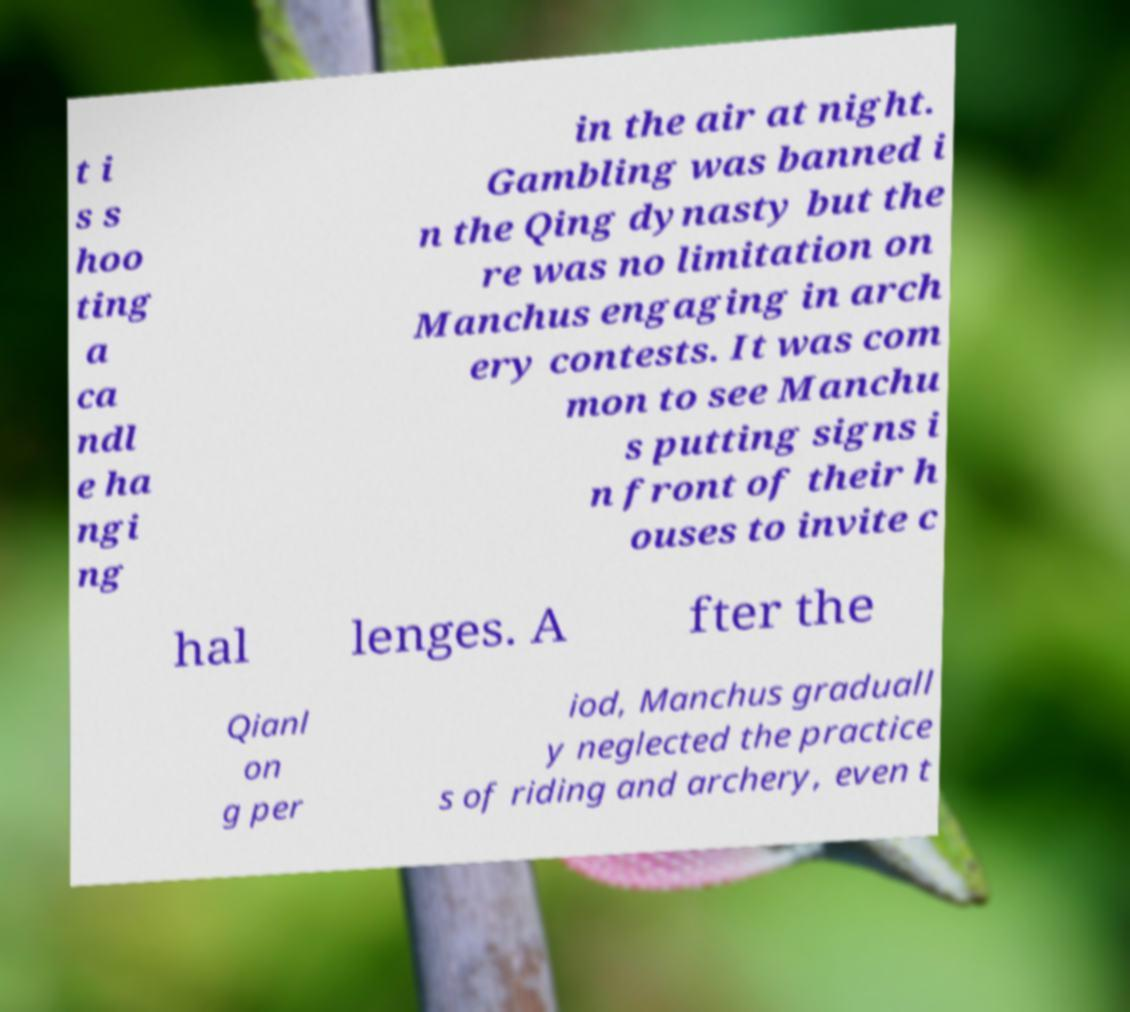Could you assist in decoding the text presented in this image and type it out clearly? t i s s hoo ting a ca ndl e ha ngi ng in the air at night. Gambling was banned i n the Qing dynasty but the re was no limitation on Manchus engaging in arch ery contests. It was com mon to see Manchu s putting signs i n front of their h ouses to invite c hal lenges. A fter the Qianl on g per iod, Manchus graduall y neglected the practice s of riding and archery, even t 